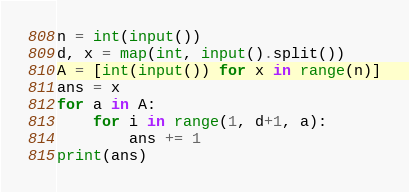<code> <loc_0><loc_0><loc_500><loc_500><_Python_>n = int(input())
d, x = map(int, input().split())
A = [int(input()) for x in range(n)]
ans = x
for a in A:
    for i in range(1, d+1, a):
        ans += 1
print(ans)</code> 